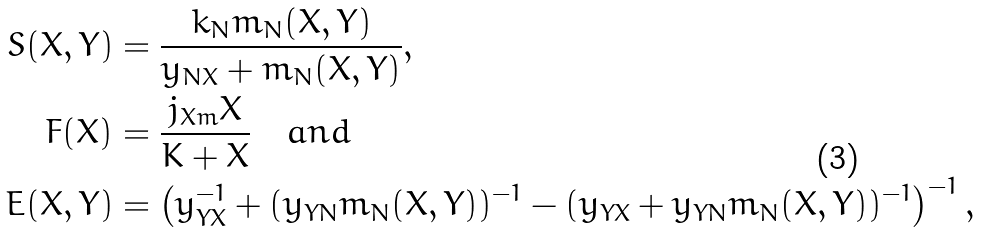Convert formula to latex. <formula><loc_0><loc_0><loc_500><loc_500>S ( X , Y ) & = \frac { k _ { N } m _ { N } ( X , Y ) } { y _ { N X } + m _ { N } ( X , Y ) } , \\ F ( X ) & = \frac { j _ { X m } X } { K + X } \quad a n d \\ E ( X , Y ) & = \left ( y _ { Y X } ^ { - 1 } + ( y _ { Y N } m _ { N } ( X , Y ) ) ^ { - 1 } - ( y _ { Y X } + y _ { Y N } m _ { N } ( X , Y ) ) ^ { - 1 } \right ) ^ { - 1 } ,</formula> 